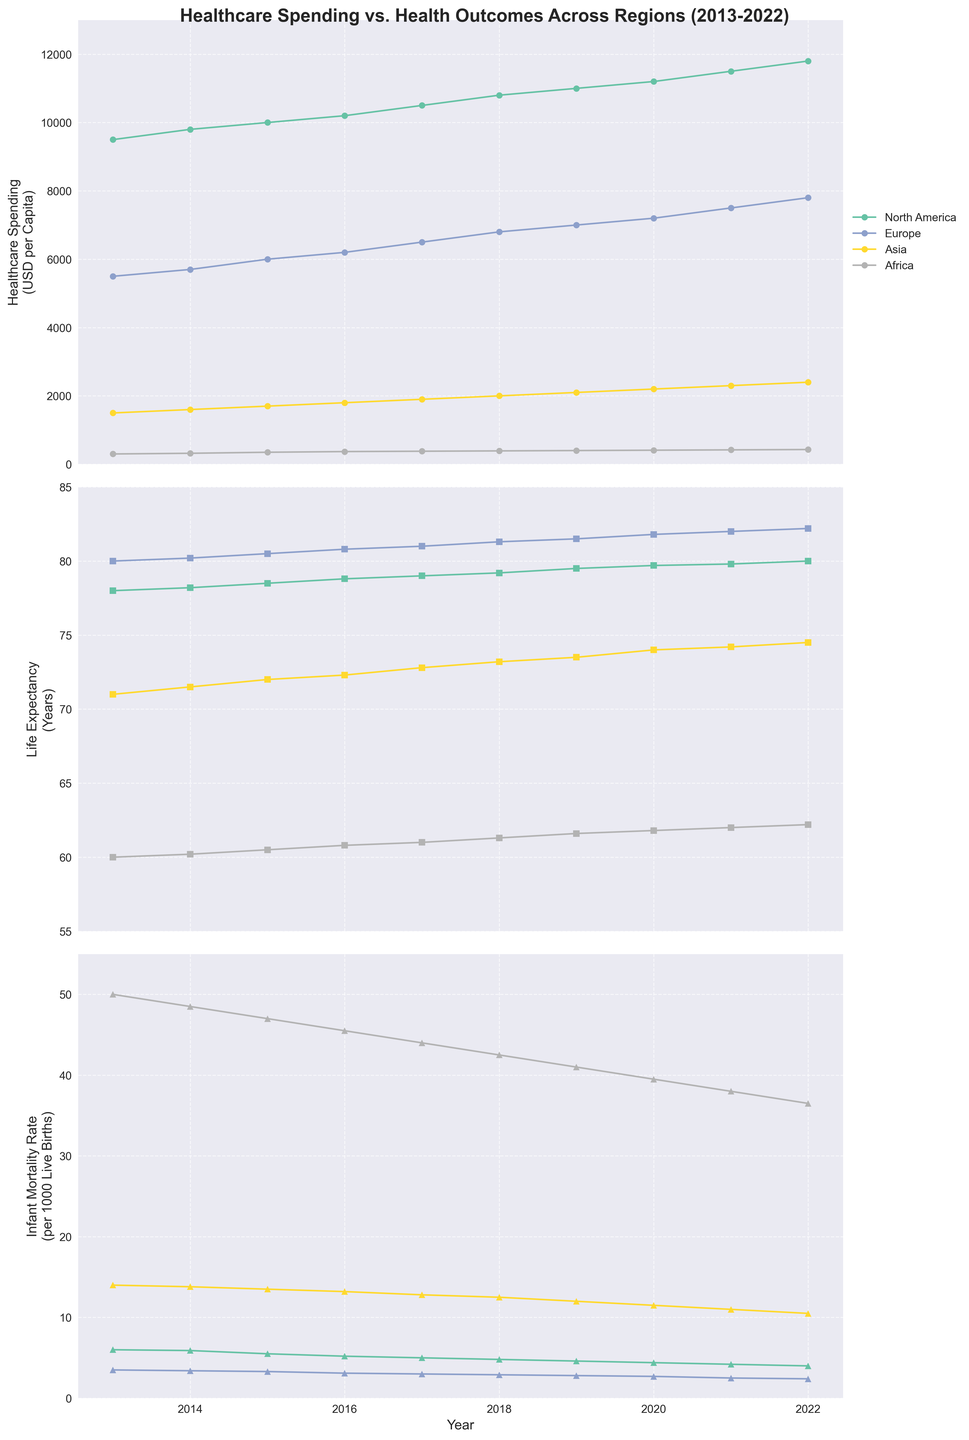What is the title of the figure? The title of the figure can be found at the top of the figure and it provides a brief summary of what the figure is about. It reads "Healthcare Spending vs. Health Outcomes Across Regions (2013-2022)".
Answer: Healthcare Spending vs. Health Outcomes Across Regions (2013-2022) Which region has the highest healthcare spending in 2022? To answer this, we need to look at the first subplot for the year 2022 and identify the region with the highest data point. The North America line has the highest point in 2022.
Answer: North America What is the trend of life expectancy in Africa over the last ten years? Examine the second subplot for the data points corresponding to Africa. The life expectancy line for Africa shows a consistent increase from 60.0 years in 2013 to 62.2 years in 2022.
Answer: Increasing How does the infant mortality rate in Asia in 2022 compare to that in 2013? Look at the third subplot for the data points corresponding to Asia for 2013 and 2022. In 2013, the rate is 14.0 per 1000 live births, and in 2022, it is 10.5 per 1000 live births. Subtract the 2022 value from the 2013 value.
Answer: It has decreased by 3.5 Which region saw the greatest improvement in life expectancy from 2013 to 2022? Compare the life expectancy lines for all regions in the second subplot. Calculate the difference for each region between 2022 and 2013 values. Europe shows the largest improvement, from 80.0 years in 2013 to 82.2 years in 2022, an increase of 2.2 years.
Answer: Europe Between North America and Europe, which region had a lower infant mortality rate throughout the period 2013-2022? Compare the infant mortality rate lines for North America and Europe in the third subplot. Observe that Europe's line remains consistently below North America's line throughout the period.
Answer: Europe What is the average healthcare spending in North America from 2013 to 2022? Add the healthcare spending values for North America from each year and divide by the number of years (10). The values are 9500, 9800, 10000, 10200, 10500, 10800, 11000, 11200, 11500, and 11800. Sum these to get 106300. Divide by 10, resulting in 10630.
Answer: 10630 Which year did Europe cross the threshold of 80 years in life expectancy? Look at the second subplot for the life expectancy line corresponding to Europe and identify the first year where it is above 80.0. This occurs in 2015 when it reaches 80.5 years.
Answer: 2015 Did healthcare spending in Asia increase or decrease from 2013 to 2022? Check the first subplot for the healthcare spending line corresponding to Asia. In 2013, the value is 1500, and in 2022, it is 2400. Thus, healthcare spending increased.
Answer: Increased 